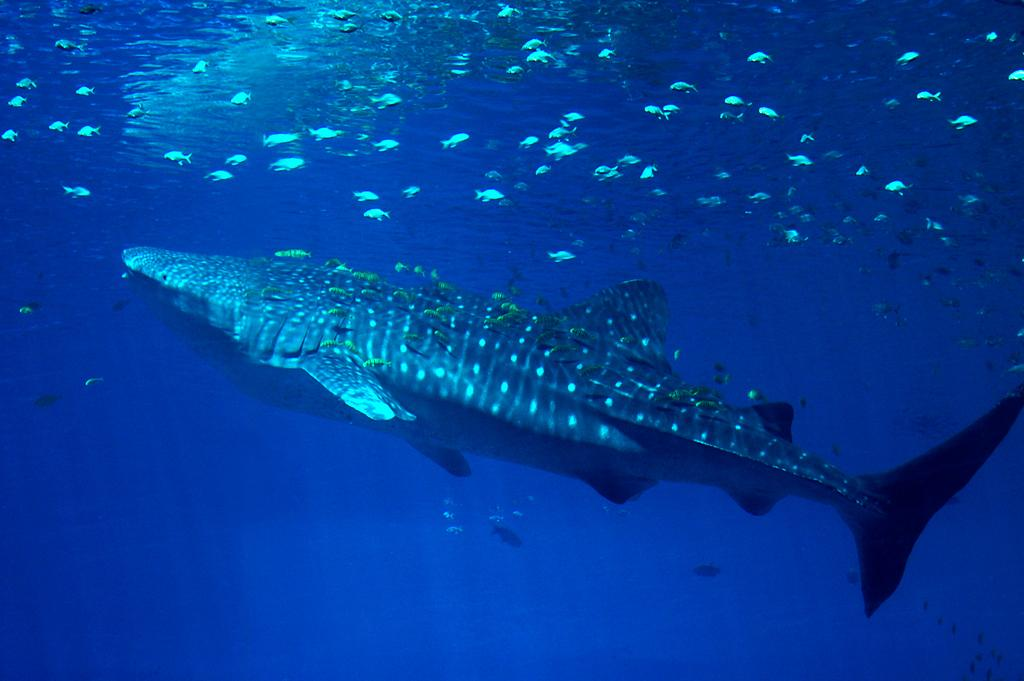What type of animal is the main subject in the image? There is a big fish in the image. Are there any other fish visible in the image? Yes, there are small fishes in the image. Where are the fish located? The fish are in the water. What type of trousers is the big fish wearing in the image? Fish do not wear trousers, so this question cannot be answered. 